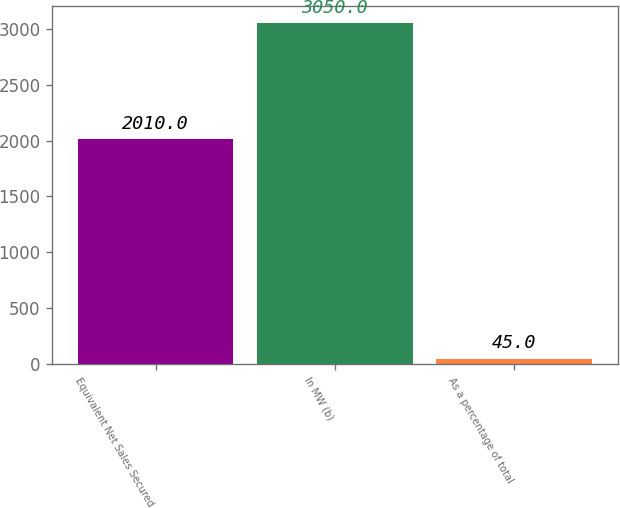Convert chart to OTSL. <chart><loc_0><loc_0><loc_500><loc_500><bar_chart><fcel>Equivalent Net Sales Secured<fcel>In MW (b)<fcel>As a percentage of total<nl><fcel>2010<fcel>3050<fcel>45<nl></chart> 